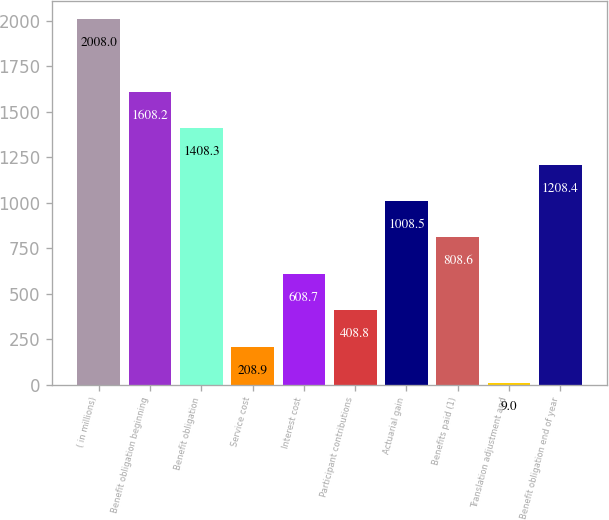Convert chart. <chart><loc_0><loc_0><loc_500><loc_500><bar_chart><fcel>( in millions)<fcel>Benefit obligation beginning<fcel>Benefit obligation<fcel>Service cost<fcel>Interest cost<fcel>Participant contributions<fcel>Actuarial gain<fcel>Benefits paid (1)<fcel>Translation adjustment and<fcel>Benefit obligation end of year<nl><fcel>2008<fcel>1608.2<fcel>1408.3<fcel>208.9<fcel>608.7<fcel>408.8<fcel>1008.5<fcel>808.6<fcel>9<fcel>1208.4<nl></chart> 